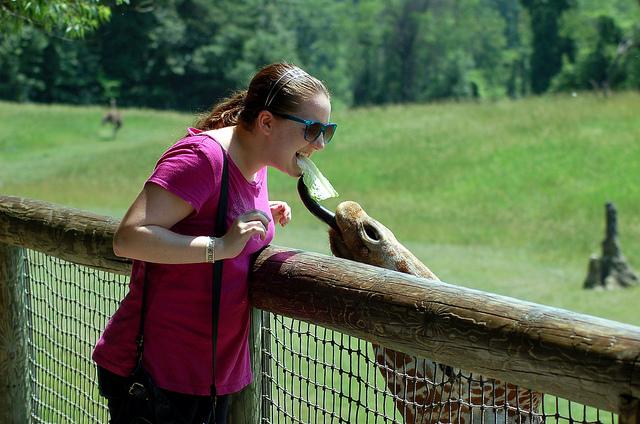What type of fence?
Give a very brief answer. Wood. What color is the woman's top?
Write a very short answer. Pink. Is it safe for the people to put their hand in the cage?
Short answer required. Yes. What animal is in the scene?
Answer briefly. Giraffe. Would this fence effective at keeping small animals out?
Be succinct. Yes. 